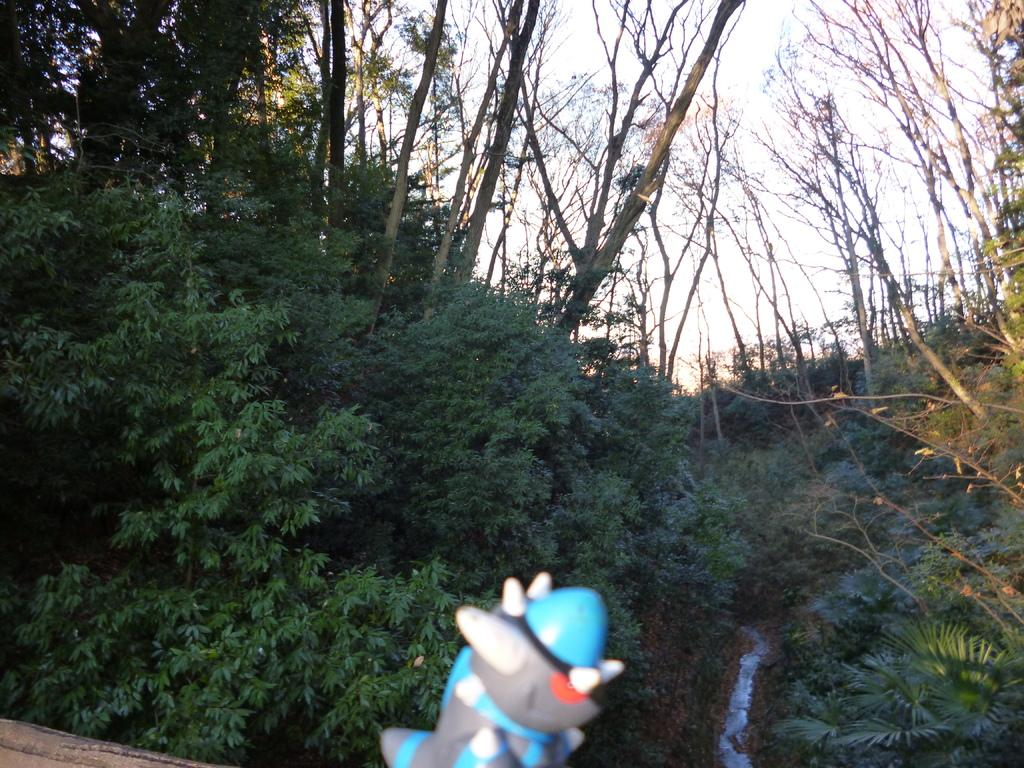Where was the image taken? The image was taken outdoors. What can be seen in the background of the image? There are many trees and plants in the background. What is visible at the top of the image? The sky is visible at the top of the image. What object is located at the bottom of the image? There is a toy at the bottom of the image. How many babies are present on the farm in the image? There are no babies or farms present in the image; it features an outdoor scene with trees, plants, sky, and a toy. What type of zinc can be seen in the image? There is no zinc present in the image. 